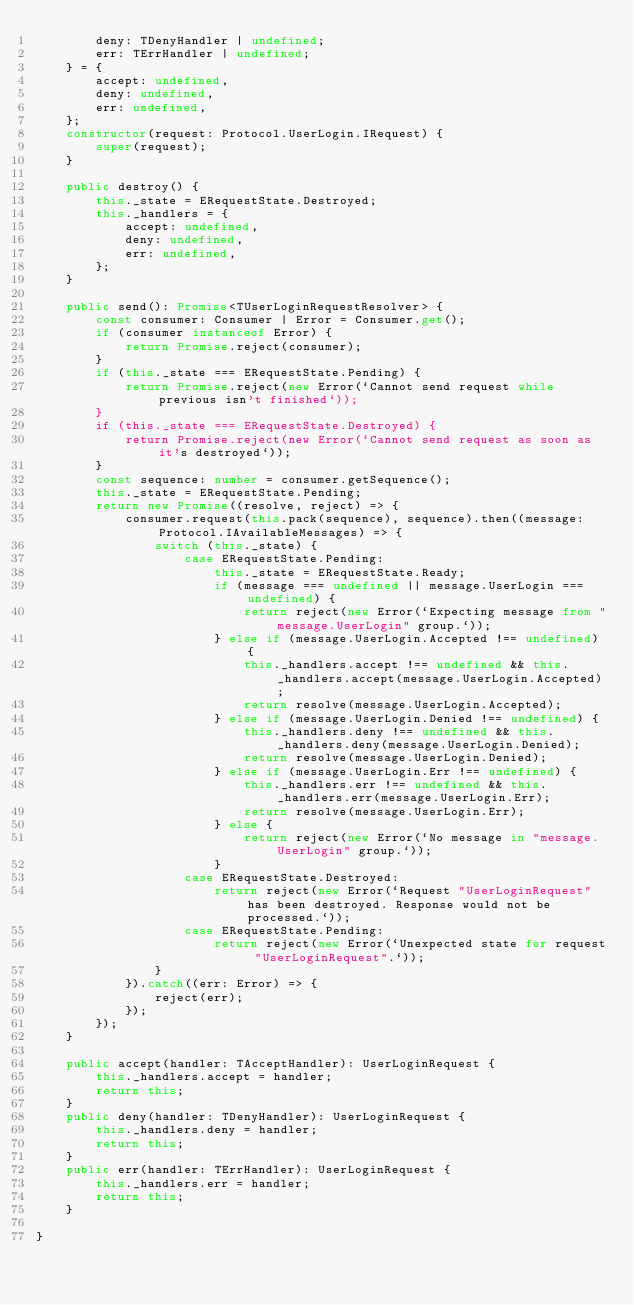Convert code to text. <code><loc_0><loc_0><loc_500><loc_500><_TypeScript_>        deny: TDenyHandler | undefined;
        err: TErrHandler | undefined;
    } = {    
        accept: undefined,
        deny: undefined,
        err: undefined,
    };
    constructor(request: Protocol.UserLogin.IRequest) {
        super(request);
    }

    public destroy() {
        this._state = ERequestState.Destroyed;
        this._handlers = {            
            accept: undefined,
            deny: undefined,
            err: undefined,
        };
    }

    public send(): Promise<TUserLoginRequestResolver> {
        const consumer: Consumer | Error = Consumer.get();
        if (consumer instanceof Error) {
            return Promise.reject(consumer);
        }
        if (this._state === ERequestState.Pending) {
            return Promise.reject(new Error(`Cannot send request while previous isn't finished`));
        }
        if (this._state === ERequestState.Destroyed) {
            return Promise.reject(new Error(`Cannot send request as soon as it's destroyed`));
        }
        const sequence: number = consumer.getSequence();
        this._state = ERequestState.Pending;
        return new Promise((resolve, reject) => {
            consumer.request(this.pack(sequence), sequence).then((message: Protocol.IAvailableMessages) => {
                switch (this._state) {
                    case ERequestState.Pending:
                        this._state = ERequestState.Ready;
                        if (message === undefined || message.UserLogin === undefined) {
                            return reject(new Error(`Expecting message from "message.UserLogin" group.`));
                        } else if (message.UserLogin.Accepted !== undefined) {
                            this._handlers.accept !== undefined && this._handlers.accept(message.UserLogin.Accepted);
                            return resolve(message.UserLogin.Accepted);
                        } else if (message.UserLogin.Denied !== undefined) {
                            this._handlers.deny !== undefined && this._handlers.deny(message.UserLogin.Denied);
                            return resolve(message.UserLogin.Denied);
                        } else if (message.UserLogin.Err !== undefined) {
                            this._handlers.err !== undefined && this._handlers.err(message.UserLogin.Err);
                            return resolve(message.UserLogin.Err);
                        } else {
                            return reject(new Error(`No message in "message.UserLogin" group.`));
                        }
                    case ERequestState.Destroyed:
                        return reject(new Error(`Request "UserLoginRequest" has been destroyed. Response would not be processed.`));
                    case ERequestState.Pending:
                        return reject(new Error(`Unexpected state for request "UserLoginRequest".`));
                }
            }).catch((err: Error) => {
                reject(err);
            });
        });
    }
    
    public accept(handler: TAcceptHandler): UserLoginRequest {
        this._handlers.accept = handler;
        return this;
    }
    public deny(handler: TDenyHandler): UserLoginRequest {
        this._handlers.deny = handler;
        return this;
    }
    public err(handler: TErrHandler): UserLoginRequest {
        this._handlers.err = handler;
        return this;
    }

}
</code> 